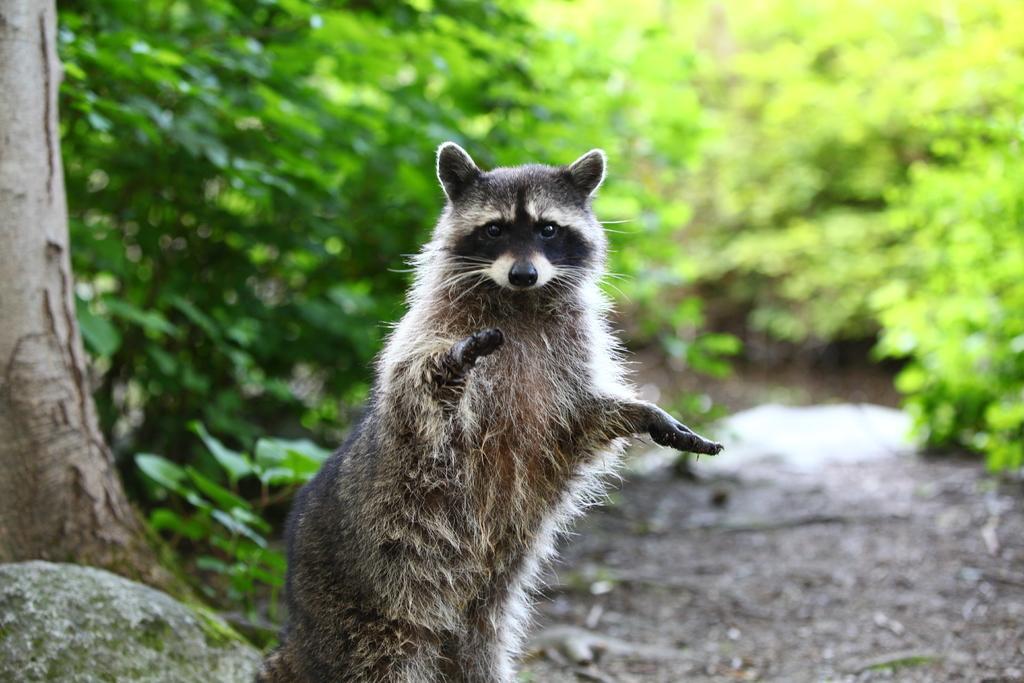Could you give a brief overview of what you see in this image? In the picture we can see a animal standing beside it we can see a rock and a tree and behind the animal we can see plants. 